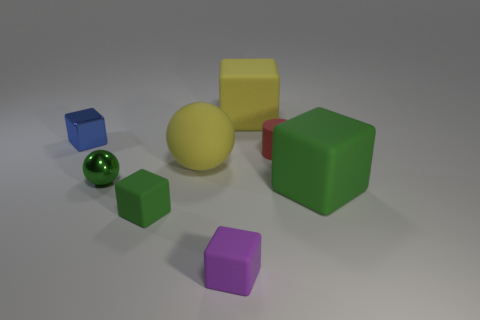Is the number of rubber cubes behind the purple matte cube less than the number of green matte things?
Make the answer very short. No. What is the color of the object to the right of the small red object?
Make the answer very short. Green. What is the shape of the blue object?
Provide a short and direct response. Cube. There is a red rubber cylinder that is on the right side of the large cube that is behind the large yellow rubber ball; is there a small cube that is behind it?
Give a very brief answer. Yes. What color is the tiny rubber block that is in front of the green matte object that is to the left of the large block on the right side of the small red cylinder?
Ensure brevity in your answer.  Purple. What is the material of the large yellow thing that is the same shape as the green shiny thing?
Your answer should be very brief. Rubber. There is a sphere that is behind the small metallic thing in front of the tiny blue shiny thing; how big is it?
Keep it short and to the point. Large. There is a large yellow object behind the blue metallic block; what is it made of?
Offer a very short reply. Rubber. What size is the cylinder that is the same material as the large green block?
Offer a terse response. Small. What number of green objects are the same shape as the purple matte object?
Ensure brevity in your answer.  2. 